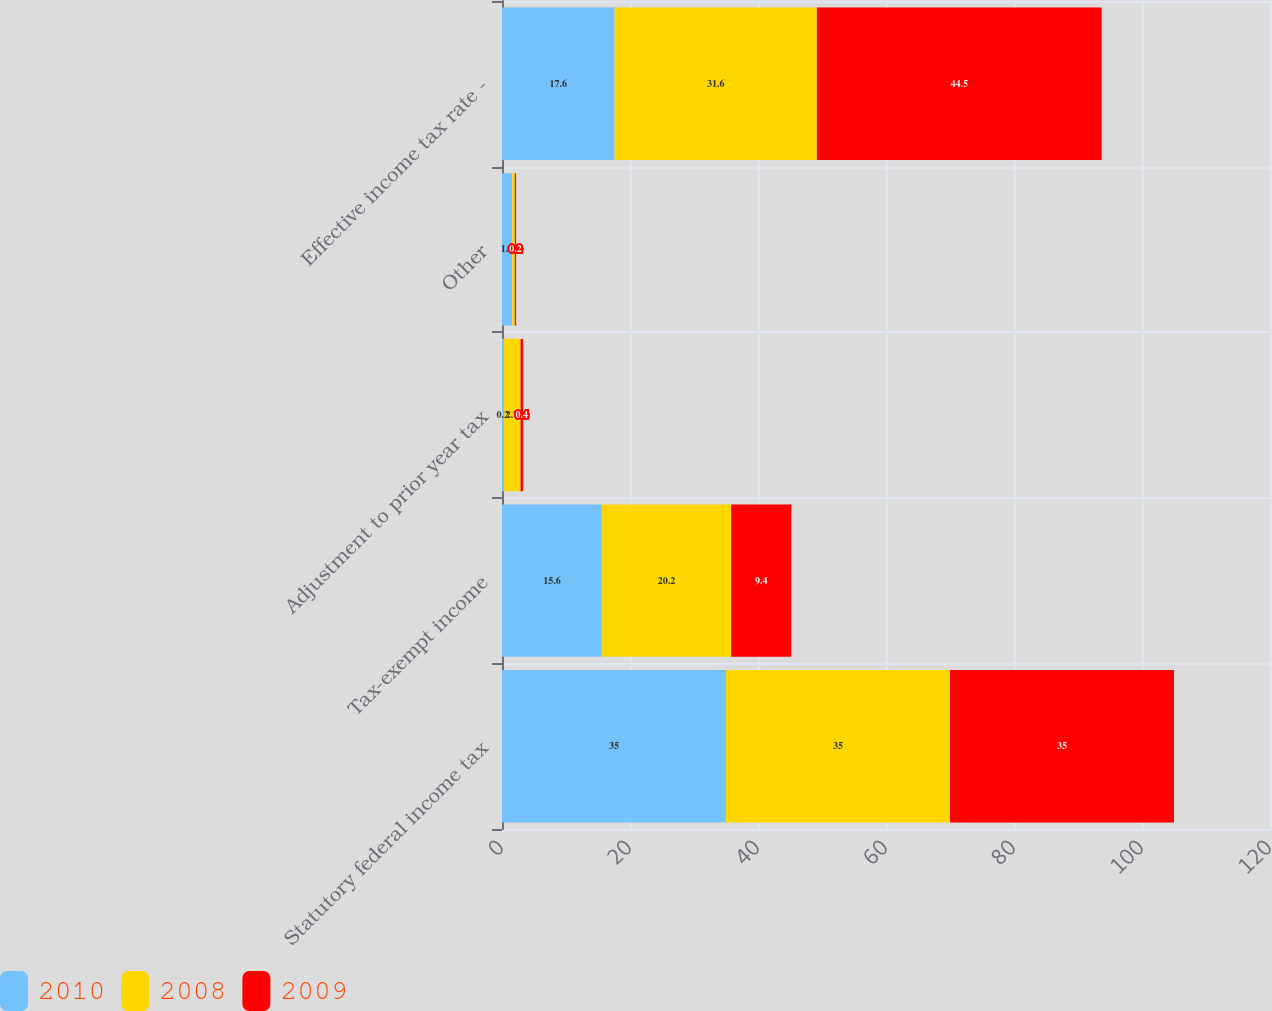Convert chart to OTSL. <chart><loc_0><loc_0><loc_500><loc_500><stacked_bar_chart><ecel><fcel>Statutory federal income tax<fcel>Tax-exempt income<fcel>Adjustment to prior year tax<fcel>Other<fcel>Effective income tax rate -<nl><fcel>2010<fcel>35<fcel>15.6<fcel>0.2<fcel>1.6<fcel>17.6<nl><fcel>2008<fcel>35<fcel>20.2<fcel>2.7<fcel>0.4<fcel>31.6<nl><fcel>2009<fcel>35<fcel>9.4<fcel>0.4<fcel>0.2<fcel>44.5<nl></chart> 